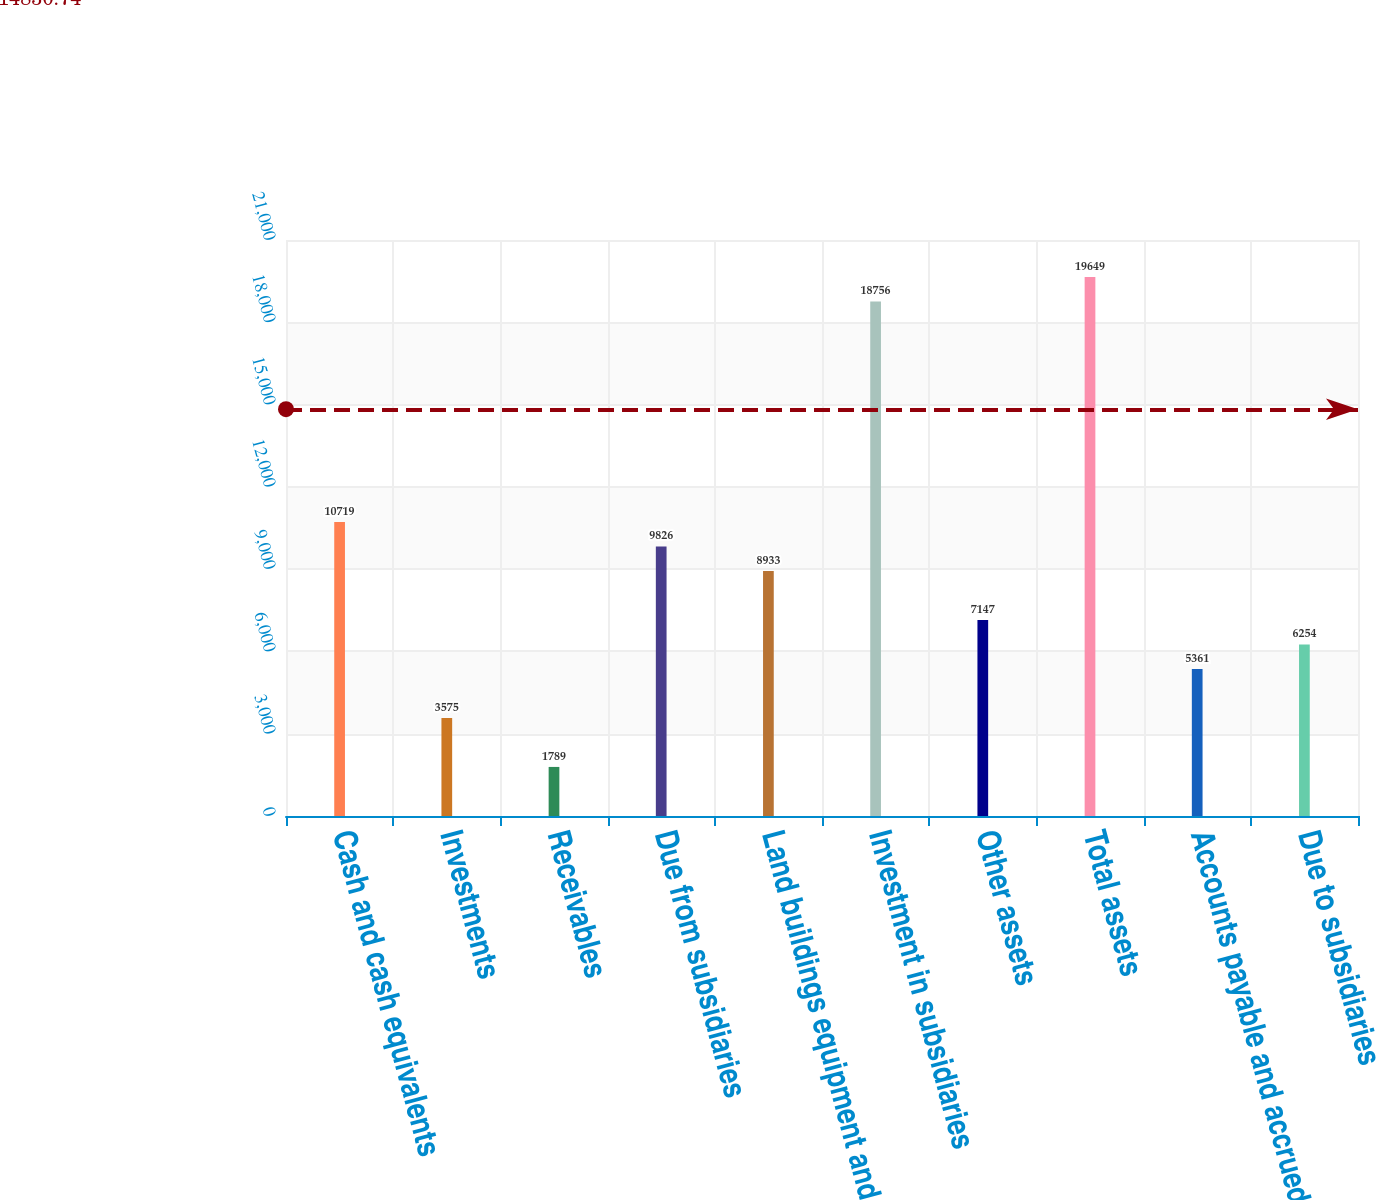Convert chart. <chart><loc_0><loc_0><loc_500><loc_500><bar_chart><fcel>Cash and cash equivalents<fcel>Investments<fcel>Receivables<fcel>Due from subsidiaries<fcel>Land buildings equipment and<fcel>Investment in subsidiaries<fcel>Other assets<fcel>Total assets<fcel>Accounts payable and accrued<fcel>Due to subsidiaries<nl><fcel>10719<fcel>3575<fcel>1789<fcel>9826<fcel>8933<fcel>18756<fcel>7147<fcel>19649<fcel>5361<fcel>6254<nl></chart> 